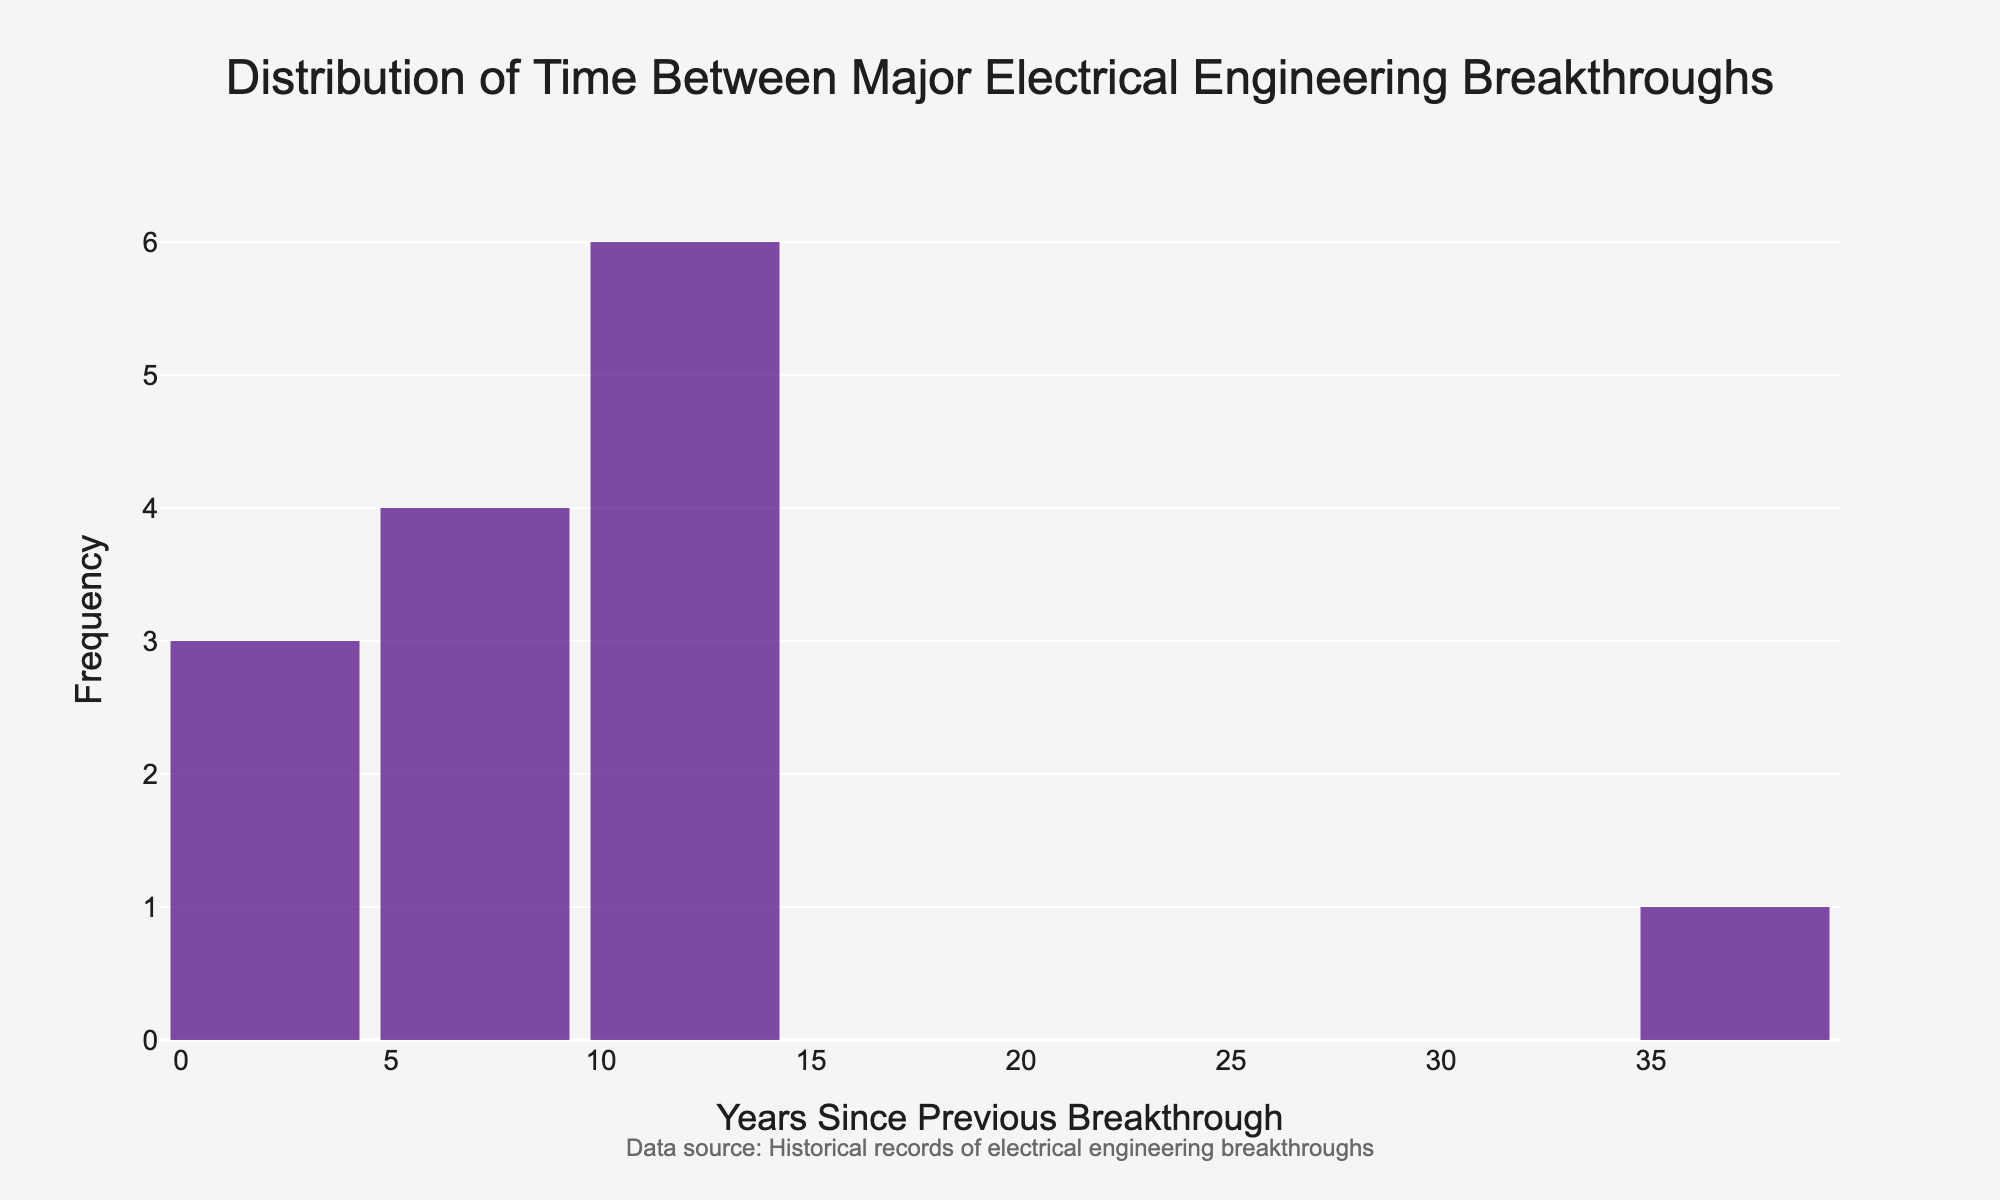How many different timespans are covered in the histogram? Look at the number of unique bars shown on the x-axis, each bar represents a different timespan.
Answer: 8 What is the title of the histogram? The title is usually located at the top center of the histogram.
Answer: Distribution of Time Between Major Electrical Engineering Breakthroughs What is the range of timespans between breakthroughs? The range is determined by identifying the smallest and largest timespan values on the x-axis.
Answer: 0 to 35 years What timespan between breakthroughs appears most frequently? Identify the bar with the highest y-value (frequency) on the histogram.
Answer: 6 years How many breakthroughs occurred within a timespan of 6 years since the previous breakthrough? Find the bar representing "6 years" on the x-axis and read its corresponding frequency on the y-axis.
Answer: 2 Are there any timespans longer than 20 years between breakthroughs? Check for any bars on the histogram that extend beyond the 20-year mark on the x-axis.
Answer: Yes What is the total number of breakthroughs depicted in the histogram? Sum the heights (frequencies) of all bars in the histogram.
Answer: 14 Which timespan, 10 years or 12 years, has more frequent occurrences? Compare the heights of the bars corresponding to "10 years" and "12 years" on the histogram.
Answer: 12 years Is there any technological breakthrough that happened immediately after the previous one? Look for a bar representing "0 years" on the x-axis.
Answer: Yes What is the average timespan between breakthroughs shown in the histogram? Add up all the timespans and then divide by the number of occurrences.
Answer: (0+12+35+3+10+6+8+11+4+9+6+14+13+12)/14 ≈ 10.07 years 